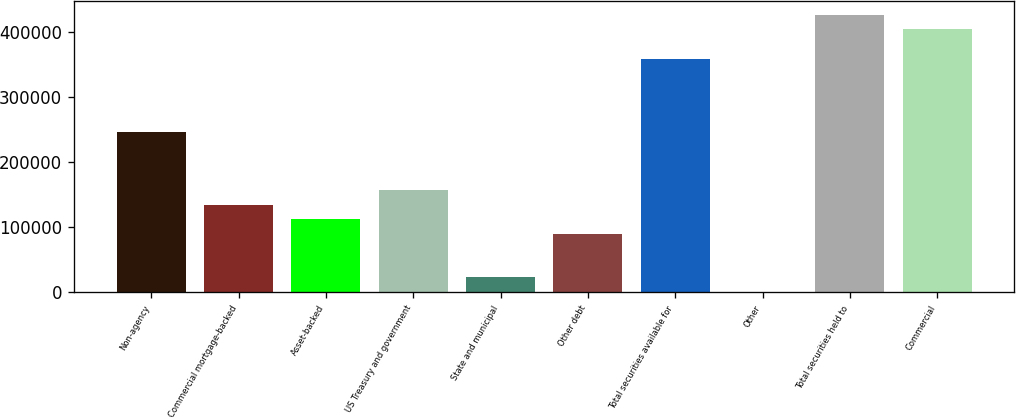Convert chart. <chart><loc_0><loc_0><loc_500><loc_500><bar_chart><fcel>Non-agency<fcel>Commercial mortgage-backed<fcel>Asset-backed<fcel>US Treasury and government<fcel>State and municipal<fcel>Other debt<fcel>Total securities available for<fcel>Other<fcel>Total securities held to<fcel>Commercial<nl><fcel>246743<fcel>134727<fcel>112324<fcel>157130<fcel>22711.2<fcel>89920.8<fcel>358759<fcel>308<fcel>425969<fcel>403566<nl></chart> 